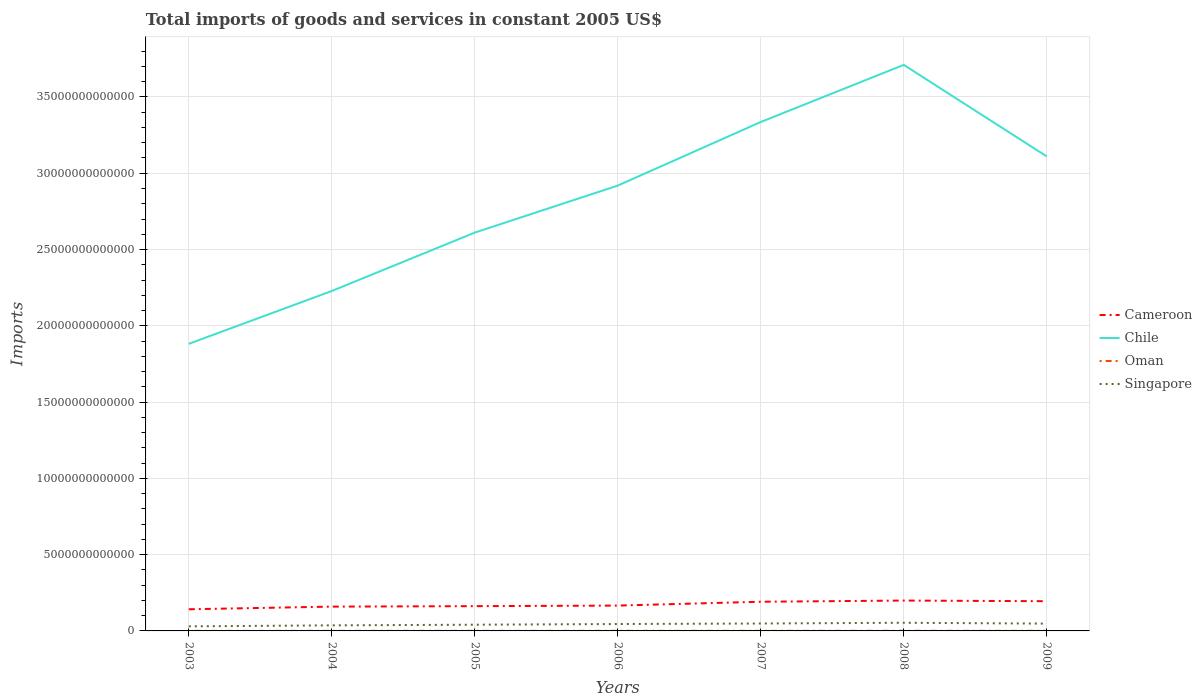How many different coloured lines are there?
Keep it short and to the point. 4. Is the number of lines equal to the number of legend labels?
Give a very brief answer. Yes. Across all years, what is the maximum total imports of goods and services in Cameroon?
Provide a succinct answer. 1.42e+12. What is the total total imports of goods and services in Cameroon in the graph?
Offer a terse response. -3.29e+11. What is the difference between the highest and the second highest total imports of goods and services in Singapore?
Your answer should be very brief. 2.36e+11. Is the total imports of goods and services in Cameroon strictly greater than the total imports of goods and services in Singapore over the years?
Make the answer very short. No. How many lines are there?
Provide a short and direct response. 4. How many years are there in the graph?
Provide a short and direct response. 7. What is the difference between two consecutive major ticks on the Y-axis?
Your response must be concise. 5.00e+12. Are the values on the major ticks of Y-axis written in scientific E-notation?
Your answer should be compact. No. Does the graph contain any zero values?
Your answer should be compact. No. Where does the legend appear in the graph?
Your answer should be compact. Center right. How many legend labels are there?
Provide a succinct answer. 4. How are the legend labels stacked?
Give a very brief answer. Vertical. What is the title of the graph?
Offer a very short reply. Total imports of goods and services in constant 2005 US$. What is the label or title of the X-axis?
Provide a succinct answer. Years. What is the label or title of the Y-axis?
Your answer should be compact. Imports. What is the Imports in Cameroon in 2003?
Your answer should be compact. 1.42e+12. What is the Imports of Chile in 2003?
Provide a short and direct response. 1.88e+13. What is the Imports of Oman in 2003?
Offer a very short reply. 3.80e+09. What is the Imports of Singapore in 2003?
Provide a succinct answer. 2.99e+11. What is the Imports in Cameroon in 2004?
Provide a succinct answer. 1.59e+12. What is the Imports in Chile in 2004?
Your response must be concise. 2.23e+13. What is the Imports in Oman in 2004?
Your answer should be compact. 4.83e+09. What is the Imports of Singapore in 2004?
Give a very brief answer. 3.65e+11. What is the Imports in Cameroon in 2005?
Keep it short and to the point. 1.62e+12. What is the Imports of Chile in 2005?
Offer a very short reply. 2.61e+13. What is the Imports of Oman in 2005?
Your response must be concise. 5.30e+09. What is the Imports in Singapore in 2005?
Give a very brief answer. 4.07e+11. What is the Imports in Cameroon in 2006?
Keep it short and to the point. 1.66e+12. What is the Imports in Chile in 2006?
Give a very brief answer. 2.92e+13. What is the Imports in Oman in 2006?
Offer a very short reply. 4.80e+09. What is the Imports in Singapore in 2006?
Provide a succinct answer. 4.53e+11. What is the Imports in Cameroon in 2007?
Provide a short and direct response. 1.91e+12. What is the Imports in Chile in 2007?
Ensure brevity in your answer.  3.34e+13. What is the Imports of Oman in 2007?
Provide a short and direct response. 6.45e+09. What is the Imports of Singapore in 2007?
Provide a succinct answer. 4.86e+11. What is the Imports of Cameroon in 2008?
Give a very brief answer. 1.99e+12. What is the Imports in Chile in 2008?
Offer a terse response. 3.71e+13. What is the Imports of Oman in 2008?
Offer a very short reply. 7.74e+09. What is the Imports in Singapore in 2008?
Your answer should be compact. 5.35e+11. What is the Imports in Cameroon in 2009?
Offer a terse response. 1.95e+12. What is the Imports of Chile in 2009?
Your answer should be compact. 3.11e+13. What is the Imports in Oman in 2009?
Provide a short and direct response. 6.02e+09. What is the Imports of Singapore in 2009?
Provide a short and direct response. 4.80e+11. Across all years, what is the maximum Imports of Cameroon?
Your response must be concise. 1.99e+12. Across all years, what is the maximum Imports in Chile?
Keep it short and to the point. 3.71e+13. Across all years, what is the maximum Imports in Oman?
Your answer should be compact. 7.74e+09. Across all years, what is the maximum Imports in Singapore?
Give a very brief answer. 5.35e+11. Across all years, what is the minimum Imports in Cameroon?
Provide a succinct answer. 1.42e+12. Across all years, what is the minimum Imports in Chile?
Ensure brevity in your answer.  1.88e+13. Across all years, what is the minimum Imports of Oman?
Give a very brief answer. 3.80e+09. Across all years, what is the minimum Imports in Singapore?
Provide a short and direct response. 2.99e+11. What is the total Imports of Cameroon in the graph?
Your response must be concise. 1.21e+13. What is the total Imports in Chile in the graph?
Provide a succinct answer. 1.98e+14. What is the total Imports of Oman in the graph?
Make the answer very short. 3.89e+1. What is the total Imports in Singapore in the graph?
Give a very brief answer. 3.02e+12. What is the difference between the Imports of Cameroon in 2003 and that in 2004?
Your response must be concise. -1.74e+11. What is the difference between the Imports of Chile in 2003 and that in 2004?
Make the answer very short. -3.46e+12. What is the difference between the Imports in Oman in 2003 and that in 2004?
Provide a short and direct response. -1.03e+09. What is the difference between the Imports of Singapore in 2003 and that in 2004?
Keep it short and to the point. -6.62e+1. What is the difference between the Imports of Cameroon in 2003 and that in 2005?
Offer a terse response. -2.04e+11. What is the difference between the Imports in Chile in 2003 and that in 2005?
Your answer should be compact. -7.29e+12. What is the difference between the Imports of Oman in 2003 and that in 2005?
Provide a short and direct response. -1.50e+09. What is the difference between the Imports of Singapore in 2003 and that in 2005?
Make the answer very short. -1.08e+11. What is the difference between the Imports in Cameroon in 2003 and that in 2006?
Ensure brevity in your answer.  -2.42e+11. What is the difference between the Imports in Chile in 2003 and that in 2006?
Offer a terse response. -1.04e+13. What is the difference between the Imports of Oman in 2003 and that in 2006?
Make the answer very short. -1.00e+09. What is the difference between the Imports in Singapore in 2003 and that in 2006?
Ensure brevity in your answer.  -1.54e+11. What is the difference between the Imports in Cameroon in 2003 and that in 2007?
Keep it short and to the point. -4.93e+11. What is the difference between the Imports of Chile in 2003 and that in 2007?
Your answer should be compact. -1.45e+13. What is the difference between the Imports in Oman in 2003 and that in 2007?
Make the answer very short. -2.65e+09. What is the difference between the Imports in Singapore in 2003 and that in 2007?
Your response must be concise. -1.88e+11. What is the difference between the Imports of Cameroon in 2003 and that in 2008?
Provide a short and direct response. -5.71e+11. What is the difference between the Imports of Chile in 2003 and that in 2008?
Your answer should be very brief. -1.83e+13. What is the difference between the Imports of Oman in 2003 and that in 2008?
Your response must be concise. -3.94e+09. What is the difference between the Imports of Singapore in 2003 and that in 2008?
Your answer should be very brief. -2.36e+11. What is the difference between the Imports in Cameroon in 2003 and that in 2009?
Keep it short and to the point. -5.28e+11. What is the difference between the Imports in Chile in 2003 and that in 2009?
Provide a succinct answer. -1.23e+13. What is the difference between the Imports of Oman in 2003 and that in 2009?
Your answer should be compact. -2.22e+09. What is the difference between the Imports of Singapore in 2003 and that in 2009?
Offer a very short reply. -1.81e+11. What is the difference between the Imports of Cameroon in 2004 and that in 2005?
Ensure brevity in your answer.  -3.04e+1. What is the difference between the Imports of Chile in 2004 and that in 2005?
Your answer should be compact. -3.83e+12. What is the difference between the Imports of Oman in 2004 and that in 2005?
Give a very brief answer. -4.75e+08. What is the difference between the Imports of Singapore in 2004 and that in 2005?
Provide a short and direct response. -4.19e+1. What is the difference between the Imports in Cameroon in 2004 and that in 2006?
Offer a very short reply. -6.79e+1. What is the difference between the Imports in Chile in 2004 and that in 2006?
Offer a terse response. -6.91e+12. What is the difference between the Imports in Oman in 2004 and that in 2006?
Make the answer very short. 2.53e+07. What is the difference between the Imports of Singapore in 2004 and that in 2006?
Make the answer very short. -8.76e+1. What is the difference between the Imports in Cameroon in 2004 and that in 2007?
Make the answer very short. -3.20e+11. What is the difference between the Imports in Chile in 2004 and that in 2007?
Offer a terse response. -1.11e+13. What is the difference between the Imports of Oman in 2004 and that in 2007?
Provide a succinct answer. -1.63e+09. What is the difference between the Imports of Singapore in 2004 and that in 2007?
Make the answer very short. -1.21e+11. What is the difference between the Imports in Cameroon in 2004 and that in 2008?
Ensure brevity in your answer.  -3.97e+11. What is the difference between the Imports of Chile in 2004 and that in 2008?
Offer a terse response. -1.48e+13. What is the difference between the Imports of Oman in 2004 and that in 2008?
Your response must be concise. -2.92e+09. What is the difference between the Imports of Singapore in 2004 and that in 2008?
Your response must be concise. -1.70e+11. What is the difference between the Imports in Cameroon in 2004 and that in 2009?
Ensure brevity in your answer.  -3.55e+11. What is the difference between the Imports in Chile in 2004 and that in 2009?
Your answer should be very brief. -8.82e+12. What is the difference between the Imports in Oman in 2004 and that in 2009?
Give a very brief answer. -1.19e+09. What is the difference between the Imports of Singapore in 2004 and that in 2009?
Make the answer very short. -1.14e+11. What is the difference between the Imports of Cameroon in 2005 and that in 2006?
Your answer should be very brief. -3.74e+1. What is the difference between the Imports of Chile in 2005 and that in 2006?
Your answer should be compact. -3.08e+12. What is the difference between the Imports of Oman in 2005 and that in 2006?
Keep it short and to the point. 5.01e+08. What is the difference between the Imports in Singapore in 2005 and that in 2006?
Offer a very short reply. -4.57e+1. What is the difference between the Imports in Cameroon in 2005 and that in 2007?
Your answer should be very brief. -2.89e+11. What is the difference between the Imports of Chile in 2005 and that in 2007?
Offer a very short reply. -7.25e+12. What is the difference between the Imports of Oman in 2005 and that in 2007?
Provide a succinct answer. -1.15e+09. What is the difference between the Imports in Singapore in 2005 and that in 2007?
Your response must be concise. -7.94e+1. What is the difference between the Imports in Cameroon in 2005 and that in 2008?
Give a very brief answer. -3.66e+11. What is the difference between the Imports in Chile in 2005 and that in 2008?
Offer a terse response. -1.10e+13. What is the difference between the Imports in Oman in 2005 and that in 2008?
Your answer should be compact. -2.44e+09. What is the difference between the Imports in Singapore in 2005 and that in 2008?
Give a very brief answer. -1.28e+11. What is the difference between the Imports in Cameroon in 2005 and that in 2009?
Provide a short and direct response. -3.24e+11. What is the difference between the Imports of Chile in 2005 and that in 2009?
Offer a terse response. -4.99e+12. What is the difference between the Imports in Oman in 2005 and that in 2009?
Provide a succinct answer. -7.13e+08. What is the difference between the Imports of Singapore in 2005 and that in 2009?
Your answer should be compact. -7.25e+1. What is the difference between the Imports in Cameroon in 2006 and that in 2007?
Offer a very short reply. -2.52e+11. What is the difference between the Imports of Chile in 2006 and that in 2007?
Provide a short and direct response. -4.17e+12. What is the difference between the Imports of Oman in 2006 and that in 2007?
Give a very brief answer. -1.65e+09. What is the difference between the Imports in Singapore in 2006 and that in 2007?
Provide a short and direct response. -3.37e+1. What is the difference between the Imports of Cameroon in 2006 and that in 2008?
Provide a succinct answer. -3.29e+11. What is the difference between the Imports of Chile in 2006 and that in 2008?
Give a very brief answer. -7.91e+12. What is the difference between the Imports of Oman in 2006 and that in 2008?
Give a very brief answer. -2.94e+09. What is the difference between the Imports in Singapore in 2006 and that in 2008?
Keep it short and to the point. -8.24e+1. What is the difference between the Imports in Cameroon in 2006 and that in 2009?
Make the answer very short. -2.87e+11. What is the difference between the Imports of Chile in 2006 and that in 2009?
Provide a short and direct response. -1.91e+12. What is the difference between the Imports in Oman in 2006 and that in 2009?
Give a very brief answer. -1.21e+09. What is the difference between the Imports in Singapore in 2006 and that in 2009?
Give a very brief answer. -2.68e+1. What is the difference between the Imports in Cameroon in 2007 and that in 2008?
Make the answer very short. -7.72e+1. What is the difference between the Imports of Chile in 2007 and that in 2008?
Give a very brief answer. -3.74e+12. What is the difference between the Imports of Oman in 2007 and that in 2008?
Provide a succinct answer. -1.29e+09. What is the difference between the Imports of Singapore in 2007 and that in 2008?
Provide a short and direct response. -4.87e+1. What is the difference between the Imports of Cameroon in 2007 and that in 2009?
Your answer should be very brief. -3.50e+1. What is the difference between the Imports of Chile in 2007 and that in 2009?
Your answer should be compact. 2.25e+12. What is the difference between the Imports in Oman in 2007 and that in 2009?
Offer a terse response. 4.37e+08. What is the difference between the Imports of Singapore in 2007 and that in 2009?
Ensure brevity in your answer.  6.91e+09. What is the difference between the Imports of Cameroon in 2008 and that in 2009?
Keep it short and to the point. 4.22e+1. What is the difference between the Imports of Chile in 2008 and that in 2009?
Offer a very short reply. 6.00e+12. What is the difference between the Imports of Oman in 2008 and that in 2009?
Provide a short and direct response. 1.73e+09. What is the difference between the Imports of Singapore in 2008 and that in 2009?
Keep it short and to the point. 5.56e+1. What is the difference between the Imports in Cameroon in 2003 and the Imports in Chile in 2004?
Your answer should be compact. -2.09e+13. What is the difference between the Imports of Cameroon in 2003 and the Imports of Oman in 2004?
Provide a succinct answer. 1.41e+12. What is the difference between the Imports of Cameroon in 2003 and the Imports of Singapore in 2004?
Your answer should be very brief. 1.05e+12. What is the difference between the Imports of Chile in 2003 and the Imports of Oman in 2004?
Your response must be concise. 1.88e+13. What is the difference between the Imports in Chile in 2003 and the Imports in Singapore in 2004?
Make the answer very short. 1.85e+13. What is the difference between the Imports in Oman in 2003 and the Imports in Singapore in 2004?
Provide a short and direct response. -3.61e+11. What is the difference between the Imports of Cameroon in 2003 and the Imports of Chile in 2005?
Your answer should be very brief. -2.47e+13. What is the difference between the Imports of Cameroon in 2003 and the Imports of Oman in 2005?
Your response must be concise. 1.41e+12. What is the difference between the Imports of Cameroon in 2003 and the Imports of Singapore in 2005?
Your answer should be very brief. 1.01e+12. What is the difference between the Imports in Chile in 2003 and the Imports in Oman in 2005?
Offer a very short reply. 1.88e+13. What is the difference between the Imports of Chile in 2003 and the Imports of Singapore in 2005?
Offer a very short reply. 1.84e+13. What is the difference between the Imports of Oman in 2003 and the Imports of Singapore in 2005?
Provide a succinct answer. -4.03e+11. What is the difference between the Imports in Cameroon in 2003 and the Imports in Chile in 2006?
Offer a terse response. -2.78e+13. What is the difference between the Imports of Cameroon in 2003 and the Imports of Oman in 2006?
Offer a very short reply. 1.41e+12. What is the difference between the Imports in Cameroon in 2003 and the Imports in Singapore in 2006?
Keep it short and to the point. 9.66e+11. What is the difference between the Imports in Chile in 2003 and the Imports in Oman in 2006?
Your response must be concise. 1.88e+13. What is the difference between the Imports in Chile in 2003 and the Imports in Singapore in 2006?
Your answer should be compact. 1.84e+13. What is the difference between the Imports of Oman in 2003 and the Imports of Singapore in 2006?
Give a very brief answer. -4.49e+11. What is the difference between the Imports in Cameroon in 2003 and the Imports in Chile in 2007?
Keep it short and to the point. -3.19e+13. What is the difference between the Imports of Cameroon in 2003 and the Imports of Oman in 2007?
Ensure brevity in your answer.  1.41e+12. What is the difference between the Imports of Cameroon in 2003 and the Imports of Singapore in 2007?
Your answer should be compact. 9.33e+11. What is the difference between the Imports in Chile in 2003 and the Imports in Oman in 2007?
Make the answer very short. 1.88e+13. What is the difference between the Imports in Chile in 2003 and the Imports in Singapore in 2007?
Your answer should be very brief. 1.83e+13. What is the difference between the Imports in Oman in 2003 and the Imports in Singapore in 2007?
Provide a short and direct response. -4.83e+11. What is the difference between the Imports in Cameroon in 2003 and the Imports in Chile in 2008?
Offer a very short reply. -3.57e+13. What is the difference between the Imports of Cameroon in 2003 and the Imports of Oman in 2008?
Your answer should be compact. 1.41e+12. What is the difference between the Imports in Cameroon in 2003 and the Imports in Singapore in 2008?
Make the answer very short. 8.84e+11. What is the difference between the Imports of Chile in 2003 and the Imports of Oman in 2008?
Your answer should be compact. 1.88e+13. What is the difference between the Imports in Chile in 2003 and the Imports in Singapore in 2008?
Ensure brevity in your answer.  1.83e+13. What is the difference between the Imports of Oman in 2003 and the Imports of Singapore in 2008?
Provide a short and direct response. -5.31e+11. What is the difference between the Imports in Cameroon in 2003 and the Imports in Chile in 2009?
Keep it short and to the point. -2.97e+13. What is the difference between the Imports of Cameroon in 2003 and the Imports of Oman in 2009?
Keep it short and to the point. 1.41e+12. What is the difference between the Imports in Cameroon in 2003 and the Imports in Singapore in 2009?
Your answer should be compact. 9.40e+11. What is the difference between the Imports of Chile in 2003 and the Imports of Oman in 2009?
Ensure brevity in your answer.  1.88e+13. What is the difference between the Imports of Chile in 2003 and the Imports of Singapore in 2009?
Provide a short and direct response. 1.83e+13. What is the difference between the Imports in Oman in 2003 and the Imports in Singapore in 2009?
Make the answer very short. -4.76e+11. What is the difference between the Imports of Cameroon in 2004 and the Imports of Chile in 2005?
Offer a very short reply. -2.45e+13. What is the difference between the Imports in Cameroon in 2004 and the Imports in Oman in 2005?
Provide a succinct answer. 1.59e+12. What is the difference between the Imports in Cameroon in 2004 and the Imports in Singapore in 2005?
Offer a very short reply. 1.19e+12. What is the difference between the Imports in Chile in 2004 and the Imports in Oman in 2005?
Ensure brevity in your answer.  2.23e+13. What is the difference between the Imports in Chile in 2004 and the Imports in Singapore in 2005?
Your response must be concise. 2.19e+13. What is the difference between the Imports of Oman in 2004 and the Imports of Singapore in 2005?
Give a very brief answer. -4.02e+11. What is the difference between the Imports in Cameroon in 2004 and the Imports in Chile in 2006?
Provide a short and direct response. -2.76e+13. What is the difference between the Imports of Cameroon in 2004 and the Imports of Oman in 2006?
Provide a succinct answer. 1.59e+12. What is the difference between the Imports in Cameroon in 2004 and the Imports in Singapore in 2006?
Offer a terse response. 1.14e+12. What is the difference between the Imports of Chile in 2004 and the Imports of Oman in 2006?
Provide a short and direct response. 2.23e+13. What is the difference between the Imports of Chile in 2004 and the Imports of Singapore in 2006?
Your answer should be compact. 2.18e+13. What is the difference between the Imports of Oman in 2004 and the Imports of Singapore in 2006?
Keep it short and to the point. -4.48e+11. What is the difference between the Imports in Cameroon in 2004 and the Imports in Chile in 2007?
Your answer should be compact. -3.18e+13. What is the difference between the Imports of Cameroon in 2004 and the Imports of Oman in 2007?
Make the answer very short. 1.59e+12. What is the difference between the Imports of Cameroon in 2004 and the Imports of Singapore in 2007?
Your answer should be very brief. 1.11e+12. What is the difference between the Imports in Chile in 2004 and the Imports in Oman in 2007?
Your answer should be compact. 2.23e+13. What is the difference between the Imports of Chile in 2004 and the Imports of Singapore in 2007?
Ensure brevity in your answer.  2.18e+13. What is the difference between the Imports in Oman in 2004 and the Imports in Singapore in 2007?
Ensure brevity in your answer.  -4.82e+11. What is the difference between the Imports in Cameroon in 2004 and the Imports in Chile in 2008?
Offer a terse response. -3.55e+13. What is the difference between the Imports in Cameroon in 2004 and the Imports in Oman in 2008?
Your response must be concise. 1.59e+12. What is the difference between the Imports of Cameroon in 2004 and the Imports of Singapore in 2008?
Offer a very short reply. 1.06e+12. What is the difference between the Imports of Chile in 2004 and the Imports of Oman in 2008?
Provide a short and direct response. 2.23e+13. What is the difference between the Imports of Chile in 2004 and the Imports of Singapore in 2008?
Keep it short and to the point. 2.17e+13. What is the difference between the Imports in Oman in 2004 and the Imports in Singapore in 2008?
Your answer should be compact. -5.30e+11. What is the difference between the Imports in Cameroon in 2004 and the Imports in Chile in 2009?
Give a very brief answer. -2.95e+13. What is the difference between the Imports of Cameroon in 2004 and the Imports of Oman in 2009?
Keep it short and to the point. 1.59e+12. What is the difference between the Imports of Cameroon in 2004 and the Imports of Singapore in 2009?
Ensure brevity in your answer.  1.11e+12. What is the difference between the Imports of Chile in 2004 and the Imports of Oman in 2009?
Offer a terse response. 2.23e+13. What is the difference between the Imports in Chile in 2004 and the Imports in Singapore in 2009?
Give a very brief answer. 2.18e+13. What is the difference between the Imports of Oman in 2004 and the Imports of Singapore in 2009?
Your answer should be compact. -4.75e+11. What is the difference between the Imports in Cameroon in 2005 and the Imports in Chile in 2006?
Offer a terse response. -2.76e+13. What is the difference between the Imports in Cameroon in 2005 and the Imports in Oman in 2006?
Your answer should be very brief. 1.62e+12. What is the difference between the Imports in Cameroon in 2005 and the Imports in Singapore in 2006?
Make the answer very short. 1.17e+12. What is the difference between the Imports in Chile in 2005 and the Imports in Oman in 2006?
Your response must be concise. 2.61e+13. What is the difference between the Imports in Chile in 2005 and the Imports in Singapore in 2006?
Provide a short and direct response. 2.57e+13. What is the difference between the Imports of Oman in 2005 and the Imports of Singapore in 2006?
Your answer should be compact. -4.47e+11. What is the difference between the Imports in Cameroon in 2005 and the Imports in Chile in 2007?
Your answer should be very brief. -3.17e+13. What is the difference between the Imports of Cameroon in 2005 and the Imports of Oman in 2007?
Ensure brevity in your answer.  1.62e+12. What is the difference between the Imports in Cameroon in 2005 and the Imports in Singapore in 2007?
Offer a terse response. 1.14e+12. What is the difference between the Imports in Chile in 2005 and the Imports in Oman in 2007?
Your response must be concise. 2.61e+13. What is the difference between the Imports in Chile in 2005 and the Imports in Singapore in 2007?
Give a very brief answer. 2.56e+13. What is the difference between the Imports of Oman in 2005 and the Imports of Singapore in 2007?
Offer a terse response. -4.81e+11. What is the difference between the Imports of Cameroon in 2005 and the Imports of Chile in 2008?
Your response must be concise. -3.55e+13. What is the difference between the Imports in Cameroon in 2005 and the Imports in Oman in 2008?
Provide a succinct answer. 1.62e+12. What is the difference between the Imports of Cameroon in 2005 and the Imports of Singapore in 2008?
Keep it short and to the point. 1.09e+12. What is the difference between the Imports of Chile in 2005 and the Imports of Oman in 2008?
Your answer should be very brief. 2.61e+13. What is the difference between the Imports of Chile in 2005 and the Imports of Singapore in 2008?
Your response must be concise. 2.56e+13. What is the difference between the Imports in Oman in 2005 and the Imports in Singapore in 2008?
Offer a very short reply. -5.30e+11. What is the difference between the Imports of Cameroon in 2005 and the Imports of Chile in 2009?
Give a very brief answer. -2.95e+13. What is the difference between the Imports of Cameroon in 2005 and the Imports of Oman in 2009?
Your answer should be very brief. 1.62e+12. What is the difference between the Imports in Cameroon in 2005 and the Imports in Singapore in 2009?
Give a very brief answer. 1.14e+12. What is the difference between the Imports of Chile in 2005 and the Imports of Oman in 2009?
Provide a succinct answer. 2.61e+13. What is the difference between the Imports in Chile in 2005 and the Imports in Singapore in 2009?
Your answer should be very brief. 2.56e+13. What is the difference between the Imports of Oman in 2005 and the Imports of Singapore in 2009?
Your answer should be compact. -4.74e+11. What is the difference between the Imports of Cameroon in 2006 and the Imports of Chile in 2007?
Offer a very short reply. -3.17e+13. What is the difference between the Imports of Cameroon in 2006 and the Imports of Oman in 2007?
Keep it short and to the point. 1.65e+12. What is the difference between the Imports of Cameroon in 2006 and the Imports of Singapore in 2007?
Ensure brevity in your answer.  1.17e+12. What is the difference between the Imports in Chile in 2006 and the Imports in Oman in 2007?
Your answer should be compact. 2.92e+13. What is the difference between the Imports in Chile in 2006 and the Imports in Singapore in 2007?
Provide a succinct answer. 2.87e+13. What is the difference between the Imports in Oman in 2006 and the Imports in Singapore in 2007?
Provide a short and direct response. -4.82e+11. What is the difference between the Imports in Cameroon in 2006 and the Imports in Chile in 2008?
Your answer should be very brief. -3.54e+13. What is the difference between the Imports in Cameroon in 2006 and the Imports in Oman in 2008?
Your answer should be compact. 1.65e+12. What is the difference between the Imports in Cameroon in 2006 and the Imports in Singapore in 2008?
Ensure brevity in your answer.  1.13e+12. What is the difference between the Imports of Chile in 2006 and the Imports of Oman in 2008?
Offer a terse response. 2.92e+13. What is the difference between the Imports of Chile in 2006 and the Imports of Singapore in 2008?
Offer a terse response. 2.87e+13. What is the difference between the Imports in Oman in 2006 and the Imports in Singapore in 2008?
Keep it short and to the point. -5.30e+11. What is the difference between the Imports in Cameroon in 2006 and the Imports in Chile in 2009?
Your answer should be very brief. -2.94e+13. What is the difference between the Imports of Cameroon in 2006 and the Imports of Oman in 2009?
Offer a very short reply. 1.65e+12. What is the difference between the Imports in Cameroon in 2006 and the Imports in Singapore in 2009?
Offer a very short reply. 1.18e+12. What is the difference between the Imports in Chile in 2006 and the Imports in Oman in 2009?
Make the answer very short. 2.92e+13. What is the difference between the Imports in Chile in 2006 and the Imports in Singapore in 2009?
Make the answer very short. 2.87e+13. What is the difference between the Imports of Oman in 2006 and the Imports of Singapore in 2009?
Keep it short and to the point. -4.75e+11. What is the difference between the Imports of Cameroon in 2007 and the Imports of Chile in 2008?
Keep it short and to the point. -3.52e+13. What is the difference between the Imports of Cameroon in 2007 and the Imports of Oman in 2008?
Offer a terse response. 1.90e+12. What is the difference between the Imports in Cameroon in 2007 and the Imports in Singapore in 2008?
Make the answer very short. 1.38e+12. What is the difference between the Imports in Chile in 2007 and the Imports in Oman in 2008?
Give a very brief answer. 3.34e+13. What is the difference between the Imports in Chile in 2007 and the Imports in Singapore in 2008?
Ensure brevity in your answer.  3.28e+13. What is the difference between the Imports of Oman in 2007 and the Imports of Singapore in 2008?
Ensure brevity in your answer.  -5.29e+11. What is the difference between the Imports of Cameroon in 2007 and the Imports of Chile in 2009?
Provide a short and direct response. -2.92e+13. What is the difference between the Imports of Cameroon in 2007 and the Imports of Oman in 2009?
Provide a short and direct response. 1.91e+12. What is the difference between the Imports in Cameroon in 2007 and the Imports in Singapore in 2009?
Your answer should be compact. 1.43e+12. What is the difference between the Imports in Chile in 2007 and the Imports in Oman in 2009?
Your response must be concise. 3.34e+13. What is the difference between the Imports of Chile in 2007 and the Imports of Singapore in 2009?
Your answer should be very brief. 3.29e+13. What is the difference between the Imports of Oman in 2007 and the Imports of Singapore in 2009?
Give a very brief answer. -4.73e+11. What is the difference between the Imports in Cameroon in 2008 and the Imports in Chile in 2009?
Offer a terse response. -2.91e+13. What is the difference between the Imports in Cameroon in 2008 and the Imports in Oman in 2009?
Provide a short and direct response. 1.98e+12. What is the difference between the Imports of Cameroon in 2008 and the Imports of Singapore in 2009?
Give a very brief answer. 1.51e+12. What is the difference between the Imports of Chile in 2008 and the Imports of Oman in 2009?
Your answer should be compact. 3.71e+13. What is the difference between the Imports in Chile in 2008 and the Imports in Singapore in 2009?
Offer a terse response. 3.66e+13. What is the difference between the Imports in Oman in 2008 and the Imports in Singapore in 2009?
Provide a succinct answer. -4.72e+11. What is the average Imports of Cameroon per year?
Keep it short and to the point. 1.74e+12. What is the average Imports of Chile per year?
Make the answer very short. 2.83e+13. What is the average Imports of Oman per year?
Make the answer very short. 5.56e+09. What is the average Imports of Singapore per year?
Offer a very short reply. 4.32e+11. In the year 2003, what is the difference between the Imports of Cameroon and Imports of Chile?
Offer a very short reply. -1.74e+13. In the year 2003, what is the difference between the Imports in Cameroon and Imports in Oman?
Offer a very short reply. 1.42e+12. In the year 2003, what is the difference between the Imports in Cameroon and Imports in Singapore?
Provide a succinct answer. 1.12e+12. In the year 2003, what is the difference between the Imports of Chile and Imports of Oman?
Your response must be concise. 1.88e+13. In the year 2003, what is the difference between the Imports in Chile and Imports in Singapore?
Provide a short and direct response. 1.85e+13. In the year 2003, what is the difference between the Imports of Oman and Imports of Singapore?
Offer a terse response. -2.95e+11. In the year 2004, what is the difference between the Imports in Cameroon and Imports in Chile?
Ensure brevity in your answer.  -2.07e+13. In the year 2004, what is the difference between the Imports of Cameroon and Imports of Oman?
Give a very brief answer. 1.59e+12. In the year 2004, what is the difference between the Imports in Cameroon and Imports in Singapore?
Your answer should be compact. 1.23e+12. In the year 2004, what is the difference between the Imports of Chile and Imports of Oman?
Your answer should be compact. 2.23e+13. In the year 2004, what is the difference between the Imports in Chile and Imports in Singapore?
Make the answer very short. 2.19e+13. In the year 2004, what is the difference between the Imports of Oman and Imports of Singapore?
Your answer should be compact. -3.60e+11. In the year 2005, what is the difference between the Imports in Cameroon and Imports in Chile?
Your response must be concise. -2.45e+13. In the year 2005, what is the difference between the Imports of Cameroon and Imports of Oman?
Make the answer very short. 1.62e+12. In the year 2005, what is the difference between the Imports in Cameroon and Imports in Singapore?
Ensure brevity in your answer.  1.22e+12. In the year 2005, what is the difference between the Imports in Chile and Imports in Oman?
Your answer should be very brief. 2.61e+13. In the year 2005, what is the difference between the Imports in Chile and Imports in Singapore?
Provide a succinct answer. 2.57e+13. In the year 2005, what is the difference between the Imports of Oman and Imports of Singapore?
Provide a succinct answer. -4.02e+11. In the year 2006, what is the difference between the Imports of Cameroon and Imports of Chile?
Make the answer very short. -2.75e+13. In the year 2006, what is the difference between the Imports in Cameroon and Imports in Oman?
Make the answer very short. 1.66e+12. In the year 2006, what is the difference between the Imports in Cameroon and Imports in Singapore?
Offer a terse response. 1.21e+12. In the year 2006, what is the difference between the Imports of Chile and Imports of Oman?
Your answer should be very brief. 2.92e+13. In the year 2006, what is the difference between the Imports in Chile and Imports in Singapore?
Offer a terse response. 2.87e+13. In the year 2006, what is the difference between the Imports in Oman and Imports in Singapore?
Offer a terse response. -4.48e+11. In the year 2007, what is the difference between the Imports of Cameroon and Imports of Chile?
Ensure brevity in your answer.  -3.14e+13. In the year 2007, what is the difference between the Imports in Cameroon and Imports in Oman?
Keep it short and to the point. 1.91e+12. In the year 2007, what is the difference between the Imports of Cameroon and Imports of Singapore?
Give a very brief answer. 1.43e+12. In the year 2007, what is the difference between the Imports of Chile and Imports of Oman?
Your response must be concise. 3.34e+13. In the year 2007, what is the difference between the Imports of Chile and Imports of Singapore?
Provide a short and direct response. 3.29e+13. In the year 2007, what is the difference between the Imports in Oman and Imports in Singapore?
Ensure brevity in your answer.  -4.80e+11. In the year 2008, what is the difference between the Imports in Cameroon and Imports in Chile?
Provide a short and direct response. -3.51e+13. In the year 2008, what is the difference between the Imports of Cameroon and Imports of Oman?
Provide a short and direct response. 1.98e+12. In the year 2008, what is the difference between the Imports in Cameroon and Imports in Singapore?
Make the answer very short. 1.45e+12. In the year 2008, what is the difference between the Imports of Chile and Imports of Oman?
Your answer should be compact. 3.71e+13. In the year 2008, what is the difference between the Imports of Chile and Imports of Singapore?
Your answer should be compact. 3.66e+13. In the year 2008, what is the difference between the Imports of Oman and Imports of Singapore?
Your answer should be compact. -5.27e+11. In the year 2009, what is the difference between the Imports of Cameroon and Imports of Chile?
Your response must be concise. -2.92e+13. In the year 2009, what is the difference between the Imports in Cameroon and Imports in Oman?
Ensure brevity in your answer.  1.94e+12. In the year 2009, what is the difference between the Imports in Cameroon and Imports in Singapore?
Keep it short and to the point. 1.47e+12. In the year 2009, what is the difference between the Imports in Chile and Imports in Oman?
Offer a very short reply. 3.11e+13. In the year 2009, what is the difference between the Imports in Chile and Imports in Singapore?
Make the answer very short. 3.06e+13. In the year 2009, what is the difference between the Imports in Oman and Imports in Singapore?
Your answer should be very brief. -4.74e+11. What is the ratio of the Imports in Cameroon in 2003 to that in 2004?
Keep it short and to the point. 0.89. What is the ratio of the Imports in Chile in 2003 to that in 2004?
Offer a very short reply. 0.84. What is the ratio of the Imports of Oman in 2003 to that in 2004?
Ensure brevity in your answer.  0.79. What is the ratio of the Imports in Singapore in 2003 to that in 2004?
Ensure brevity in your answer.  0.82. What is the ratio of the Imports of Cameroon in 2003 to that in 2005?
Offer a very short reply. 0.87. What is the ratio of the Imports of Chile in 2003 to that in 2005?
Make the answer very short. 0.72. What is the ratio of the Imports in Oman in 2003 to that in 2005?
Offer a very short reply. 0.72. What is the ratio of the Imports in Singapore in 2003 to that in 2005?
Offer a terse response. 0.73. What is the ratio of the Imports of Cameroon in 2003 to that in 2006?
Provide a short and direct response. 0.85. What is the ratio of the Imports in Chile in 2003 to that in 2006?
Give a very brief answer. 0.64. What is the ratio of the Imports in Oman in 2003 to that in 2006?
Provide a short and direct response. 0.79. What is the ratio of the Imports in Singapore in 2003 to that in 2006?
Your answer should be very brief. 0.66. What is the ratio of the Imports of Cameroon in 2003 to that in 2007?
Give a very brief answer. 0.74. What is the ratio of the Imports in Chile in 2003 to that in 2007?
Ensure brevity in your answer.  0.56. What is the ratio of the Imports in Oman in 2003 to that in 2007?
Keep it short and to the point. 0.59. What is the ratio of the Imports in Singapore in 2003 to that in 2007?
Provide a succinct answer. 0.61. What is the ratio of the Imports in Cameroon in 2003 to that in 2008?
Keep it short and to the point. 0.71. What is the ratio of the Imports of Chile in 2003 to that in 2008?
Make the answer very short. 0.51. What is the ratio of the Imports of Oman in 2003 to that in 2008?
Ensure brevity in your answer.  0.49. What is the ratio of the Imports in Singapore in 2003 to that in 2008?
Make the answer very short. 0.56. What is the ratio of the Imports of Cameroon in 2003 to that in 2009?
Provide a short and direct response. 0.73. What is the ratio of the Imports of Chile in 2003 to that in 2009?
Offer a very short reply. 0.6. What is the ratio of the Imports of Oman in 2003 to that in 2009?
Provide a short and direct response. 0.63. What is the ratio of the Imports of Singapore in 2003 to that in 2009?
Ensure brevity in your answer.  0.62. What is the ratio of the Imports in Cameroon in 2004 to that in 2005?
Your answer should be compact. 0.98. What is the ratio of the Imports of Chile in 2004 to that in 2005?
Make the answer very short. 0.85. What is the ratio of the Imports in Oman in 2004 to that in 2005?
Provide a succinct answer. 0.91. What is the ratio of the Imports in Singapore in 2004 to that in 2005?
Offer a terse response. 0.9. What is the ratio of the Imports of Cameroon in 2004 to that in 2006?
Your answer should be very brief. 0.96. What is the ratio of the Imports of Chile in 2004 to that in 2006?
Make the answer very short. 0.76. What is the ratio of the Imports of Singapore in 2004 to that in 2006?
Your answer should be very brief. 0.81. What is the ratio of the Imports of Cameroon in 2004 to that in 2007?
Give a very brief answer. 0.83. What is the ratio of the Imports of Chile in 2004 to that in 2007?
Your answer should be compact. 0.67. What is the ratio of the Imports of Oman in 2004 to that in 2007?
Ensure brevity in your answer.  0.75. What is the ratio of the Imports in Singapore in 2004 to that in 2007?
Keep it short and to the point. 0.75. What is the ratio of the Imports in Cameroon in 2004 to that in 2008?
Your answer should be very brief. 0.8. What is the ratio of the Imports of Chile in 2004 to that in 2008?
Offer a very short reply. 0.6. What is the ratio of the Imports of Oman in 2004 to that in 2008?
Ensure brevity in your answer.  0.62. What is the ratio of the Imports in Singapore in 2004 to that in 2008?
Your answer should be very brief. 0.68. What is the ratio of the Imports in Cameroon in 2004 to that in 2009?
Make the answer very short. 0.82. What is the ratio of the Imports of Chile in 2004 to that in 2009?
Provide a succinct answer. 0.72. What is the ratio of the Imports of Oman in 2004 to that in 2009?
Provide a short and direct response. 0.8. What is the ratio of the Imports in Singapore in 2004 to that in 2009?
Provide a short and direct response. 0.76. What is the ratio of the Imports in Cameroon in 2005 to that in 2006?
Keep it short and to the point. 0.98. What is the ratio of the Imports of Chile in 2005 to that in 2006?
Offer a terse response. 0.89. What is the ratio of the Imports in Oman in 2005 to that in 2006?
Give a very brief answer. 1.1. What is the ratio of the Imports of Singapore in 2005 to that in 2006?
Your response must be concise. 0.9. What is the ratio of the Imports of Cameroon in 2005 to that in 2007?
Offer a terse response. 0.85. What is the ratio of the Imports of Chile in 2005 to that in 2007?
Offer a very short reply. 0.78. What is the ratio of the Imports in Oman in 2005 to that in 2007?
Provide a short and direct response. 0.82. What is the ratio of the Imports in Singapore in 2005 to that in 2007?
Keep it short and to the point. 0.84. What is the ratio of the Imports in Cameroon in 2005 to that in 2008?
Keep it short and to the point. 0.82. What is the ratio of the Imports of Chile in 2005 to that in 2008?
Keep it short and to the point. 0.7. What is the ratio of the Imports in Oman in 2005 to that in 2008?
Provide a short and direct response. 0.68. What is the ratio of the Imports in Singapore in 2005 to that in 2008?
Offer a very short reply. 0.76. What is the ratio of the Imports in Cameroon in 2005 to that in 2009?
Provide a short and direct response. 0.83. What is the ratio of the Imports of Chile in 2005 to that in 2009?
Your answer should be compact. 0.84. What is the ratio of the Imports in Oman in 2005 to that in 2009?
Ensure brevity in your answer.  0.88. What is the ratio of the Imports of Singapore in 2005 to that in 2009?
Provide a short and direct response. 0.85. What is the ratio of the Imports in Cameroon in 2006 to that in 2007?
Provide a short and direct response. 0.87. What is the ratio of the Imports in Oman in 2006 to that in 2007?
Provide a short and direct response. 0.74. What is the ratio of the Imports of Singapore in 2006 to that in 2007?
Offer a very short reply. 0.93. What is the ratio of the Imports in Cameroon in 2006 to that in 2008?
Keep it short and to the point. 0.83. What is the ratio of the Imports in Chile in 2006 to that in 2008?
Keep it short and to the point. 0.79. What is the ratio of the Imports in Oman in 2006 to that in 2008?
Keep it short and to the point. 0.62. What is the ratio of the Imports in Singapore in 2006 to that in 2008?
Offer a very short reply. 0.85. What is the ratio of the Imports of Cameroon in 2006 to that in 2009?
Provide a succinct answer. 0.85. What is the ratio of the Imports in Chile in 2006 to that in 2009?
Provide a succinct answer. 0.94. What is the ratio of the Imports of Oman in 2006 to that in 2009?
Ensure brevity in your answer.  0.8. What is the ratio of the Imports in Singapore in 2006 to that in 2009?
Make the answer very short. 0.94. What is the ratio of the Imports of Cameroon in 2007 to that in 2008?
Make the answer very short. 0.96. What is the ratio of the Imports of Chile in 2007 to that in 2008?
Provide a short and direct response. 0.9. What is the ratio of the Imports in Singapore in 2007 to that in 2008?
Provide a succinct answer. 0.91. What is the ratio of the Imports of Chile in 2007 to that in 2009?
Offer a terse response. 1.07. What is the ratio of the Imports of Oman in 2007 to that in 2009?
Provide a short and direct response. 1.07. What is the ratio of the Imports in Singapore in 2007 to that in 2009?
Offer a very short reply. 1.01. What is the ratio of the Imports in Cameroon in 2008 to that in 2009?
Ensure brevity in your answer.  1.02. What is the ratio of the Imports of Chile in 2008 to that in 2009?
Your answer should be compact. 1.19. What is the ratio of the Imports in Oman in 2008 to that in 2009?
Keep it short and to the point. 1.29. What is the ratio of the Imports of Singapore in 2008 to that in 2009?
Make the answer very short. 1.12. What is the difference between the highest and the second highest Imports in Cameroon?
Provide a short and direct response. 4.22e+1. What is the difference between the highest and the second highest Imports in Chile?
Your answer should be compact. 3.74e+12. What is the difference between the highest and the second highest Imports of Oman?
Your answer should be compact. 1.29e+09. What is the difference between the highest and the second highest Imports of Singapore?
Provide a succinct answer. 4.87e+1. What is the difference between the highest and the lowest Imports of Cameroon?
Provide a succinct answer. 5.71e+11. What is the difference between the highest and the lowest Imports in Chile?
Your answer should be very brief. 1.83e+13. What is the difference between the highest and the lowest Imports in Oman?
Provide a succinct answer. 3.94e+09. What is the difference between the highest and the lowest Imports in Singapore?
Offer a very short reply. 2.36e+11. 